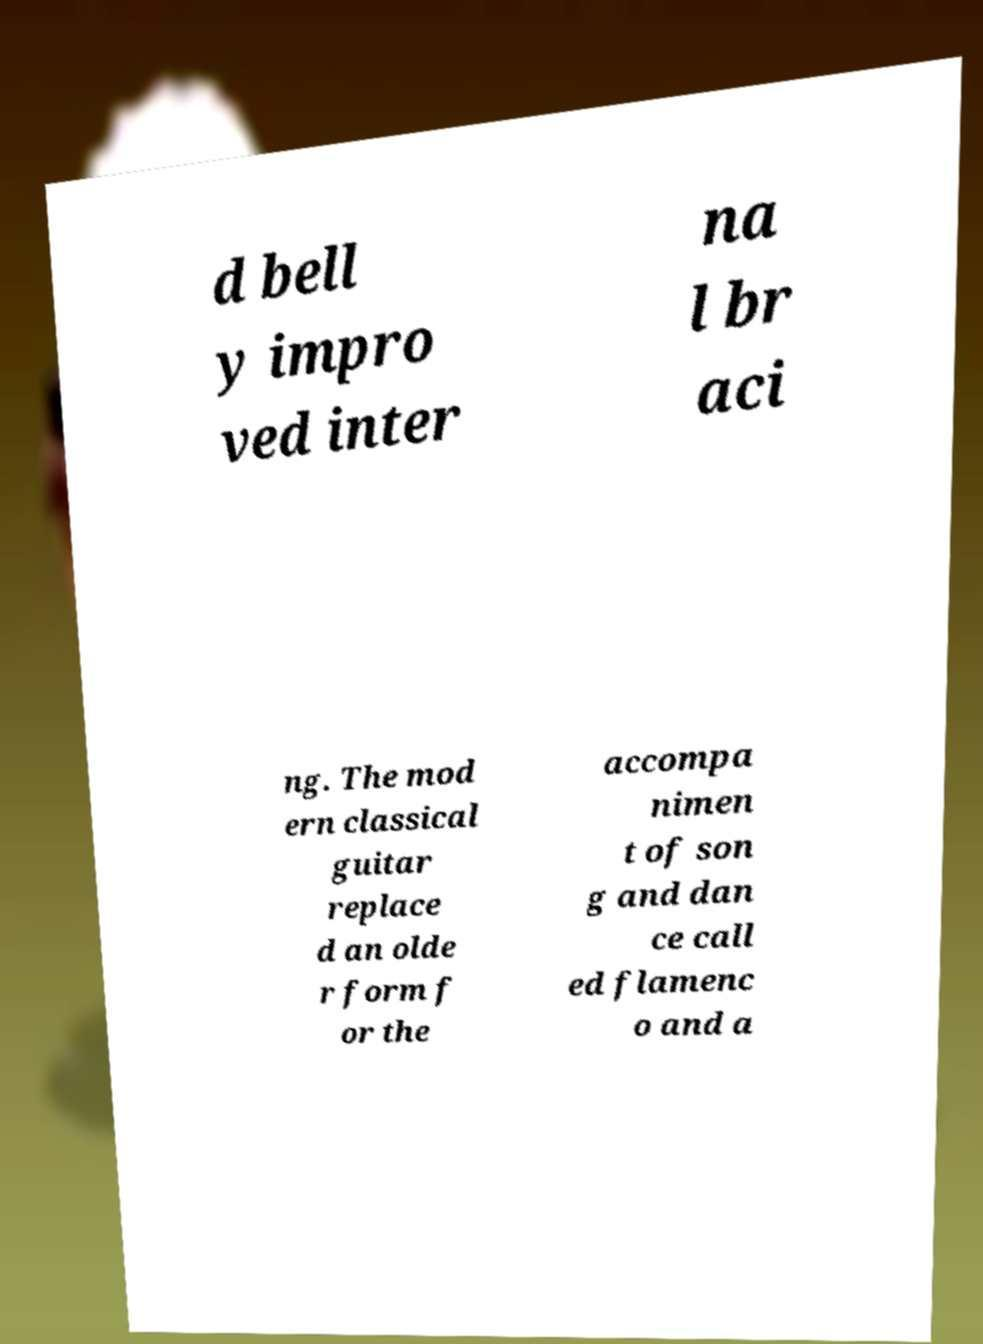Could you extract and type out the text from this image? d bell y impro ved inter na l br aci ng. The mod ern classical guitar replace d an olde r form f or the accompa nimen t of son g and dan ce call ed flamenc o and a 